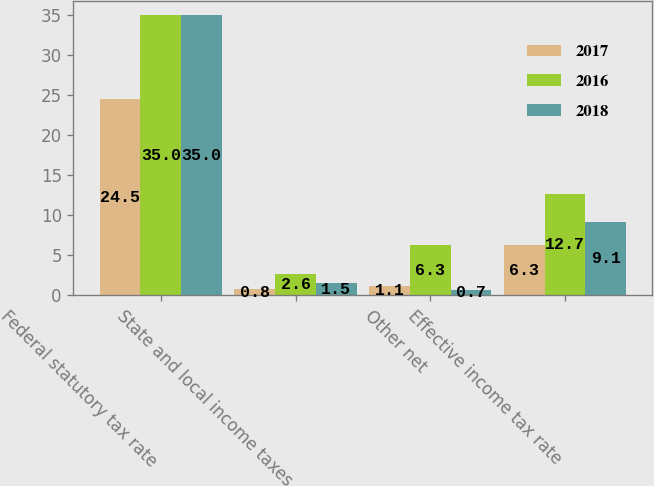Convert chart to OTSL. <chart><loc_0><loc_0><loc_500><loc_500><stacked_bar_chart><ecel><fcel>Federal statutory tax rate<fcel>State and local income taxes<fcel>Other net<fcel>Effective income tax rate<nl><fcel>2017<fcel>24.5<fcel>0.8<fcel>1.1<fcel>6.3<nl><fcel>2016<fcel>35<fcel>2.6<fcel>6.3<fcel>12.7<nl><fcel>2018<fcel>35<fcel>1.5<fcel>0.7<fcel>9.1<nl></chart> 